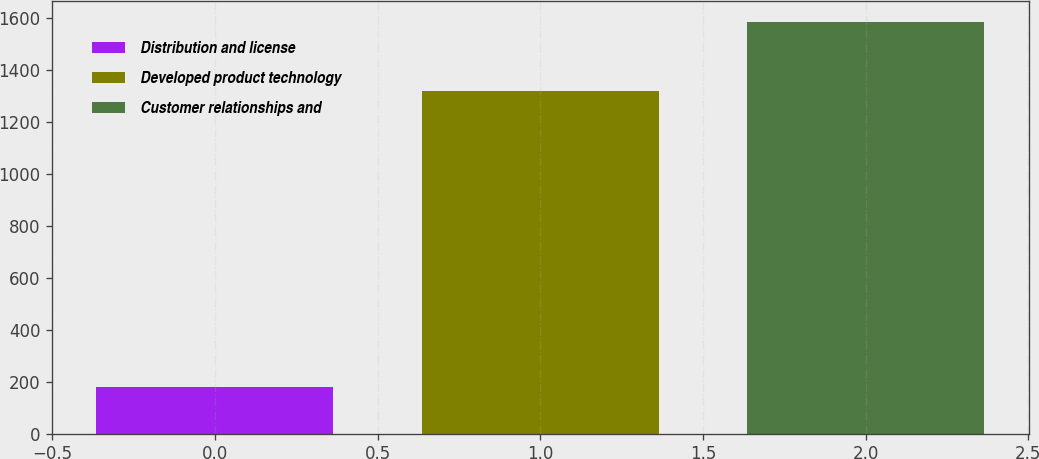Convert chart. <chart><loc_0><loc_0><loc_500><loc_500><bar_chart><fcel>Distribution and license<fcel>Developed product technology<fcel>Customer relationships and<nl><fcel>178.6<fcel>1318.8<fcel>1586.6<nl></chart> 